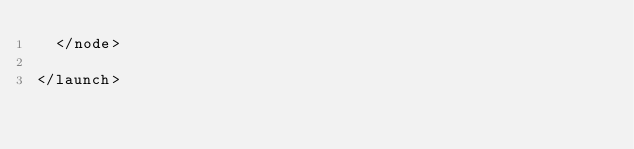Convert code to text. <code><loc_0><loc_0><loc_500><loc_500><_XML_>  </node>

</launch>
</code> 